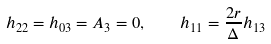Convert formula to latex. <formula><loc_0><loc_0><loc_500><loc_500>h _ { 2 2 } = h _ { 0 3 } = A _ { 3 } = 0 , \quad h _ { 1 1 } = \frac { 2 r } { \Delta } h _ { 1 3 }</formula> 